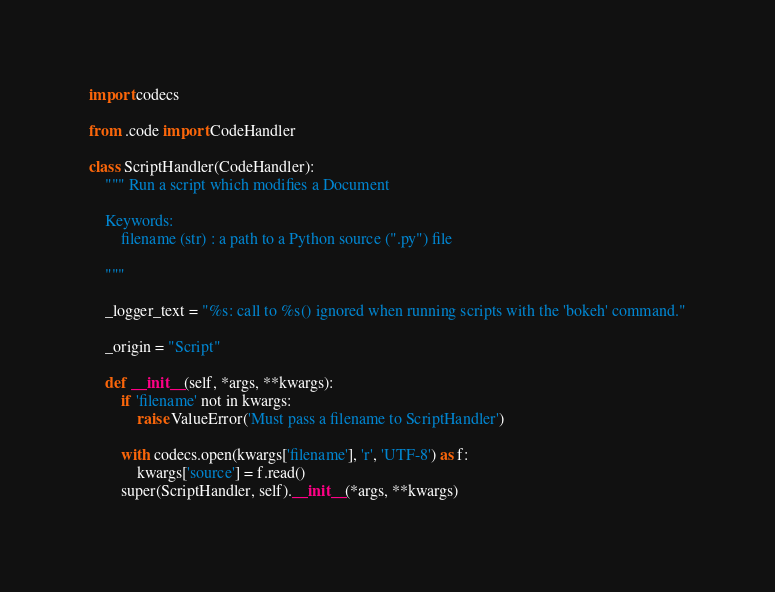Convert code to text. <code><loc_0><loc_0><loc_500><loc_500><_Python_>import codecs

from .code import CodeHandler

class ScriptHandler(CodeHandler):
    """ Run a script which modifies a Document

    Keywords:
        filename (str) : a path to a Python source (".py") file

    """

    _logger_text = "%s: call to %s() ignored when running scripts with the 'bokeh' command."

    _origin = "Script"

    def __init__(self, *args, **kwargs):
        if 'filename' not in kwargs:
            raise ValueError('Must pass a filename to ScriptHandler')

        with codecs.open(kwargs['filename'], 'r', 'UTF-8') as f:
            kwargs['source'] = f.read()
        super(ScriptHandler, self).__init__(*args, **kwargs)


</code> 